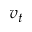Convert formula to latex. <formula><loc_0><loc_0><loc_500><loc_500>v _ { t }</formula> 